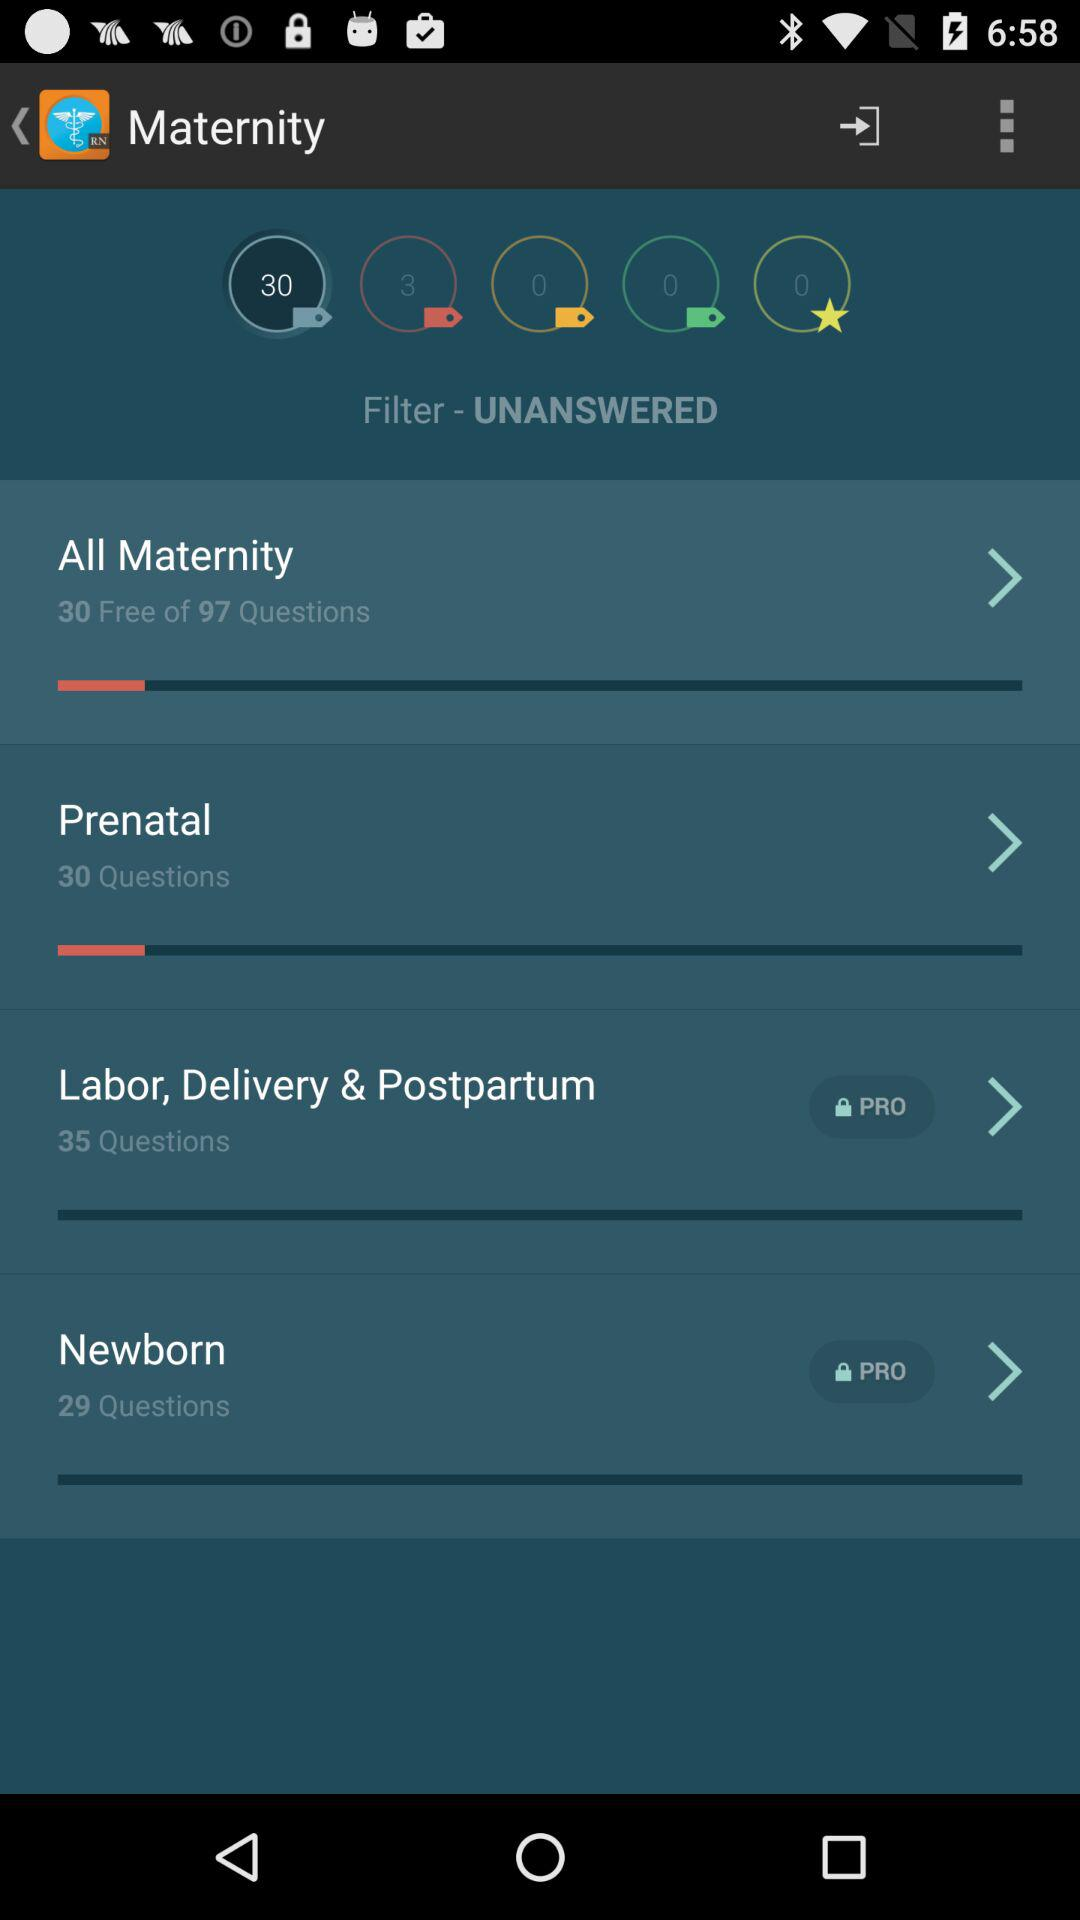How many questions are there in "Prenatal"? There are 30 questions in "Prenatal". 